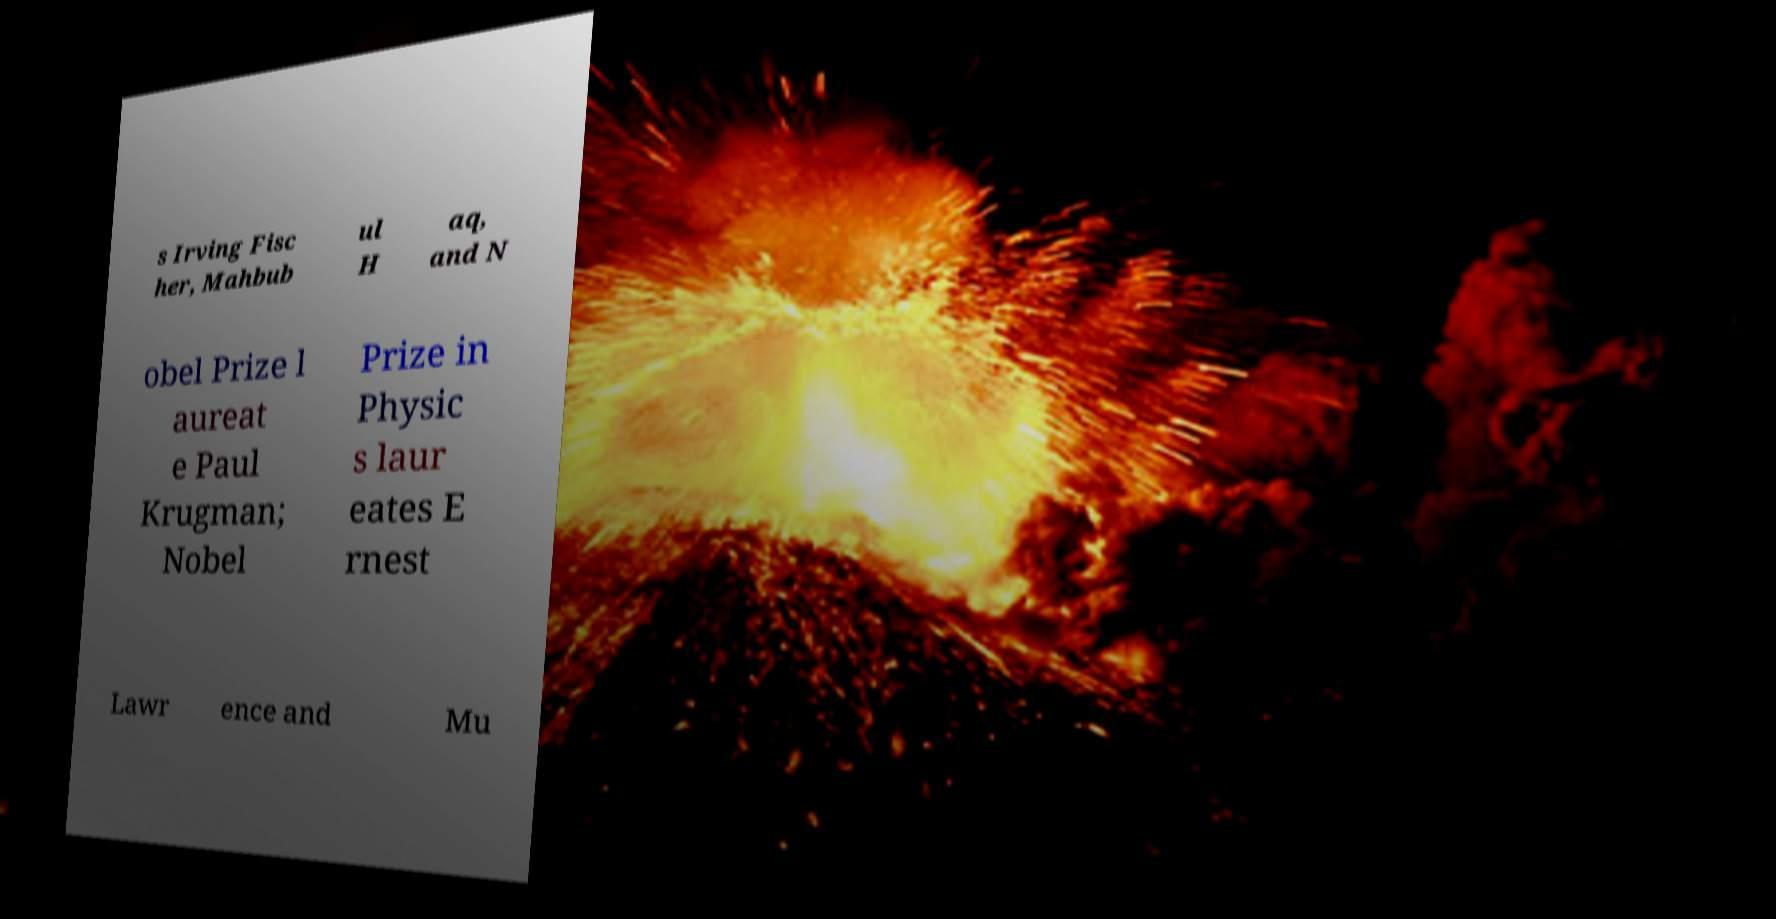Could you assist in decoding the text presented in this image and type it out clearly? s Irving Fisc her, Mahbub ul H aq, and N obel Prize l aureat e Paul Krugman; Nobel Prize in Physic s laur eates E rnest Lawr ence and Mu 